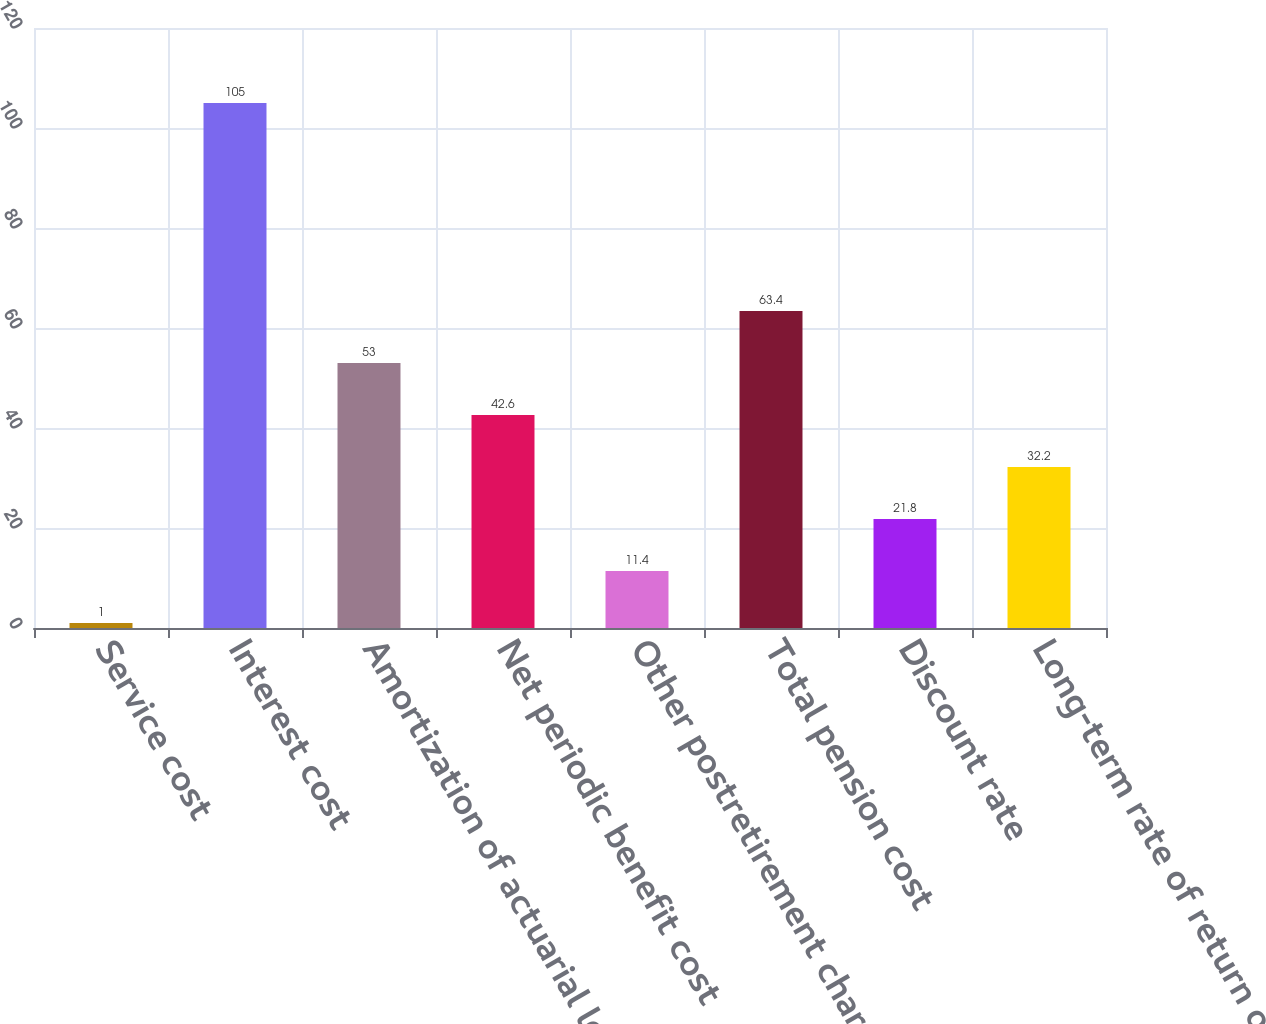<chart> <loc_0><loc_0><loc_500><loc_500><bar_chart><fcel>Service cost<fcel>Interest cost<fcel>Amortization of actuarial loss<fcel>Net periodic benefit cost<fcel>Other postretirement charges<fcel>Total pension cost<fcel>Discount rate<fcel>Long-term rate of return on<nl><fcel>1<fcel>105<fcel>53<fcel>42.6<fcel>11.4<fcel>63.4<fcel>21.8<fcel>32.2<nl></chart> 